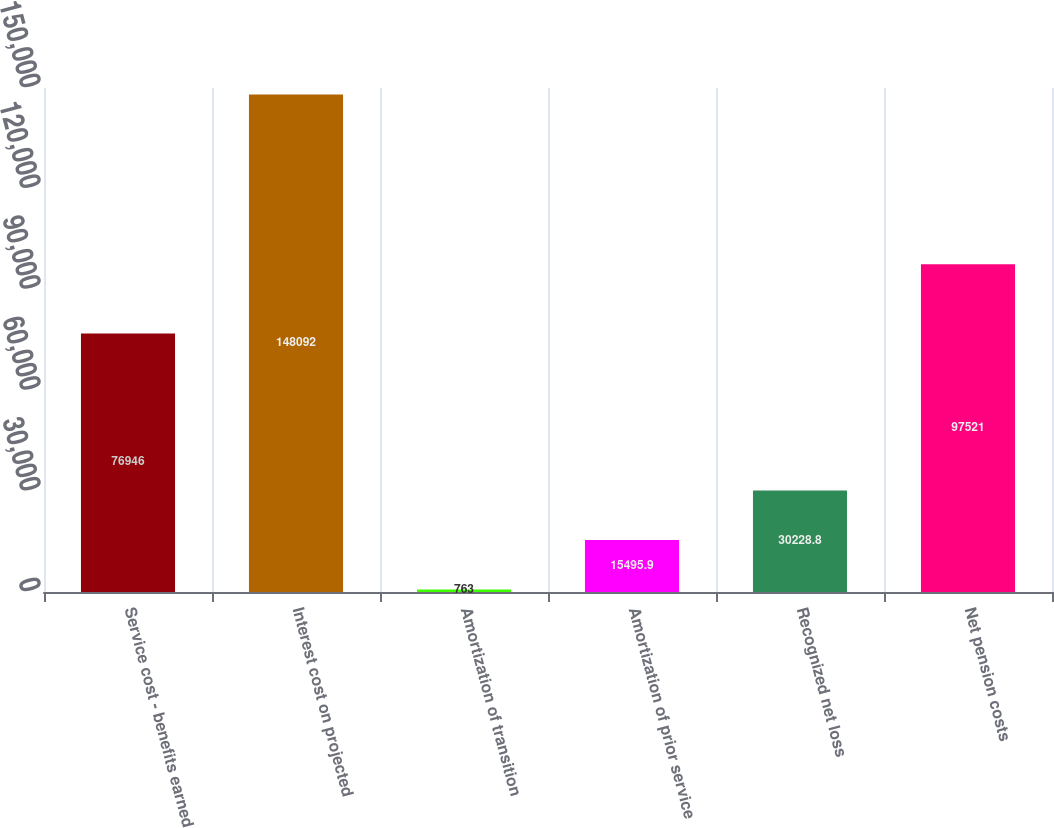Convert chart. <chart><loc_0><loc_0><loc_500><loc_500><bar_chart><fcel>Service cost - benefits earned<fcel>Interest cost on projected<fcel>Amortization of transition<fcel>Amortization of prior service<fcel>Recognized net loss<fcel>Net pension costs<nl><fcel>76946<fcel>148092<fcel>763<fcel>15495.9<fcel>30228.8<fcel>97521<nl></chart> 